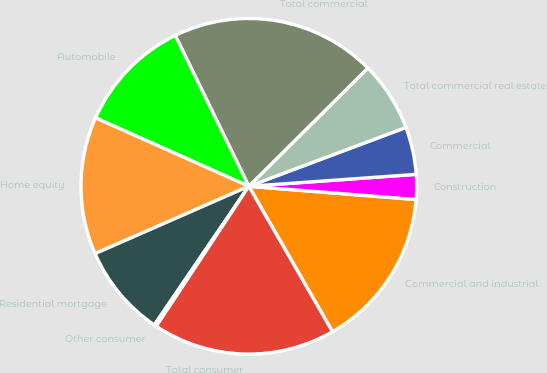<chart> <loc_0><loc_0><loc_500><loc_500><pie_chart><fcel>Commercial and industrial<fcel>Construction<fcel>Commercial<fcel>Total commercial real estate<fcel>Total commercial<fcel>Automobile<fcel>Home equity<fcel>Residential mortgage<fcel>Other consumer<fcel>Total consumer<nl><fcel>15.43%<fcel>2.39%<fcel>4.57%<fcel>6.74%<fcel>19.78%<fcel>11.09%<fcel>13.26%<fcel>8.91%<fcel>0.22%<fcel>17.61%<nl></chart> 